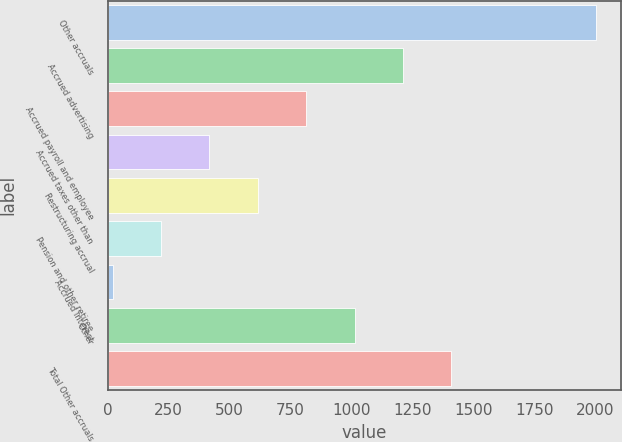Convert chart to OTSL. <chart><loc_0><loc_0><loc_500><loc_500><bar_chart><fcel>Other accruals<fcel>Accrued advertising<fcel>Accrued payroll and employee<fcel>Accrued taxes other than<fcel>Restructuring accrual<fcel>Pension and other retiree<fcel>Accrued interest<fcel>Other<fcel>Total Other accruals<nl><fcel>2006<fcel>1211.24<fcel>813.86<fcel>416.48<fcel>615.17<fcel>217.79<fcel>19.1<fcel>1012.55<fcel>1409.93<nl></chart> 